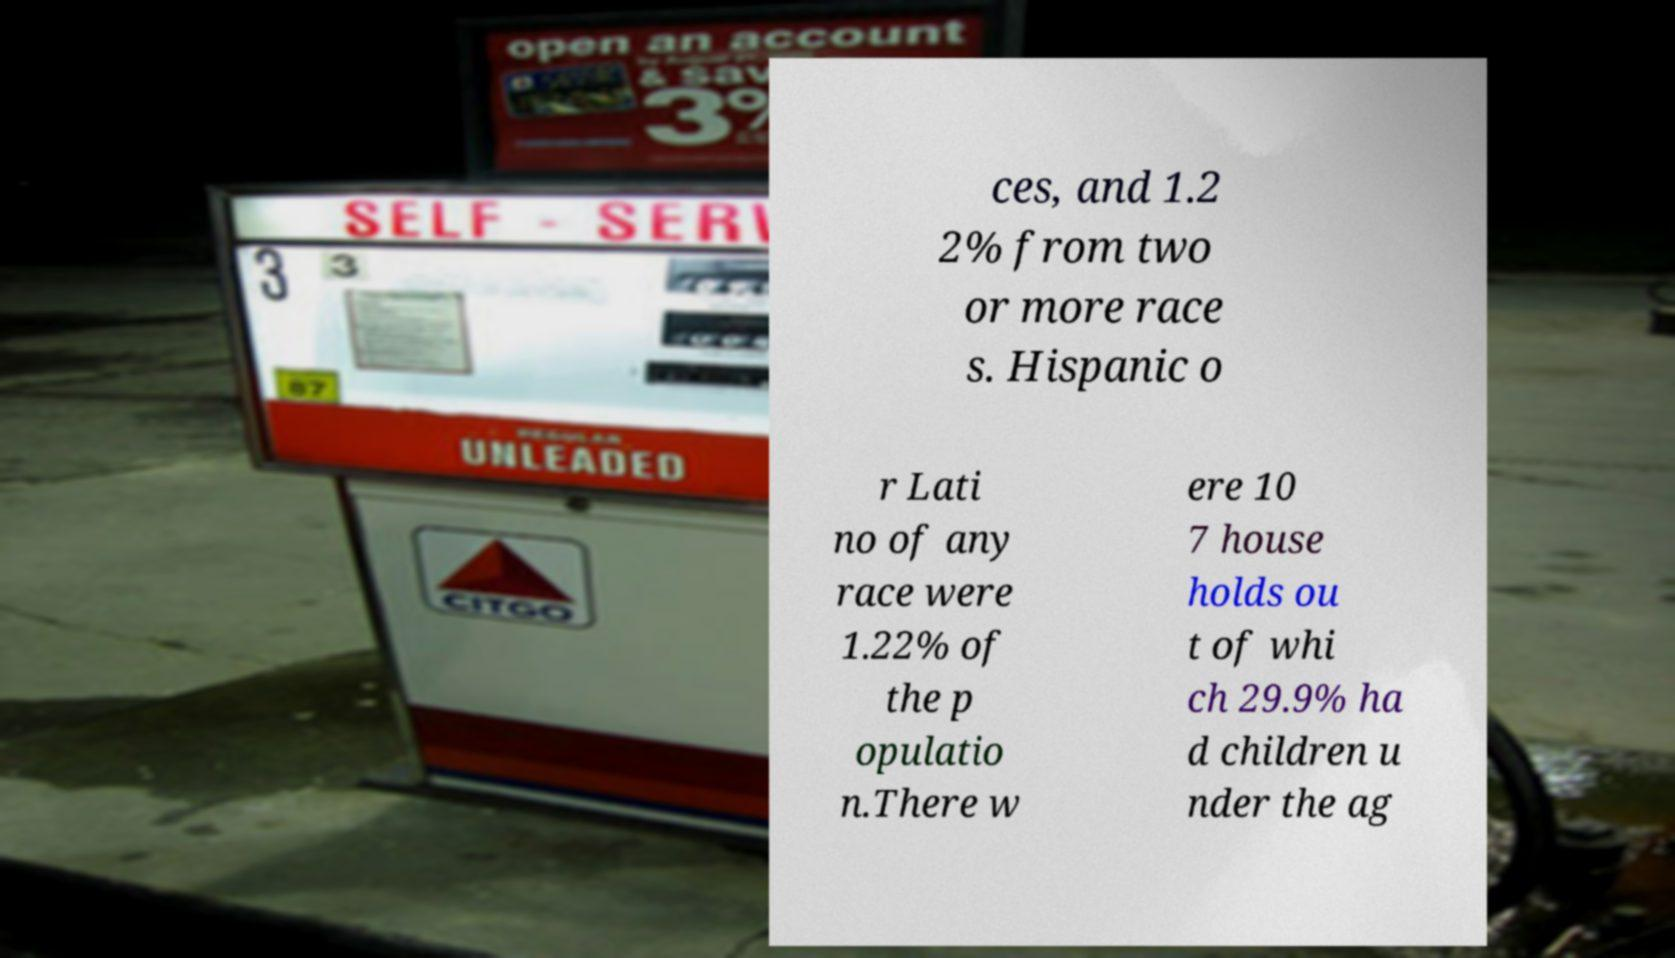For documentation purposes, I need the text within this image transcribed. Could you provide that? ces, and 1.2 2% from two or more race s. Hispanic o r Lati no of any race were 1.22% of the p opulatio n.There w ere 10 7 house holds ou t of whi ch 29.9% ha d children u nder the ag 